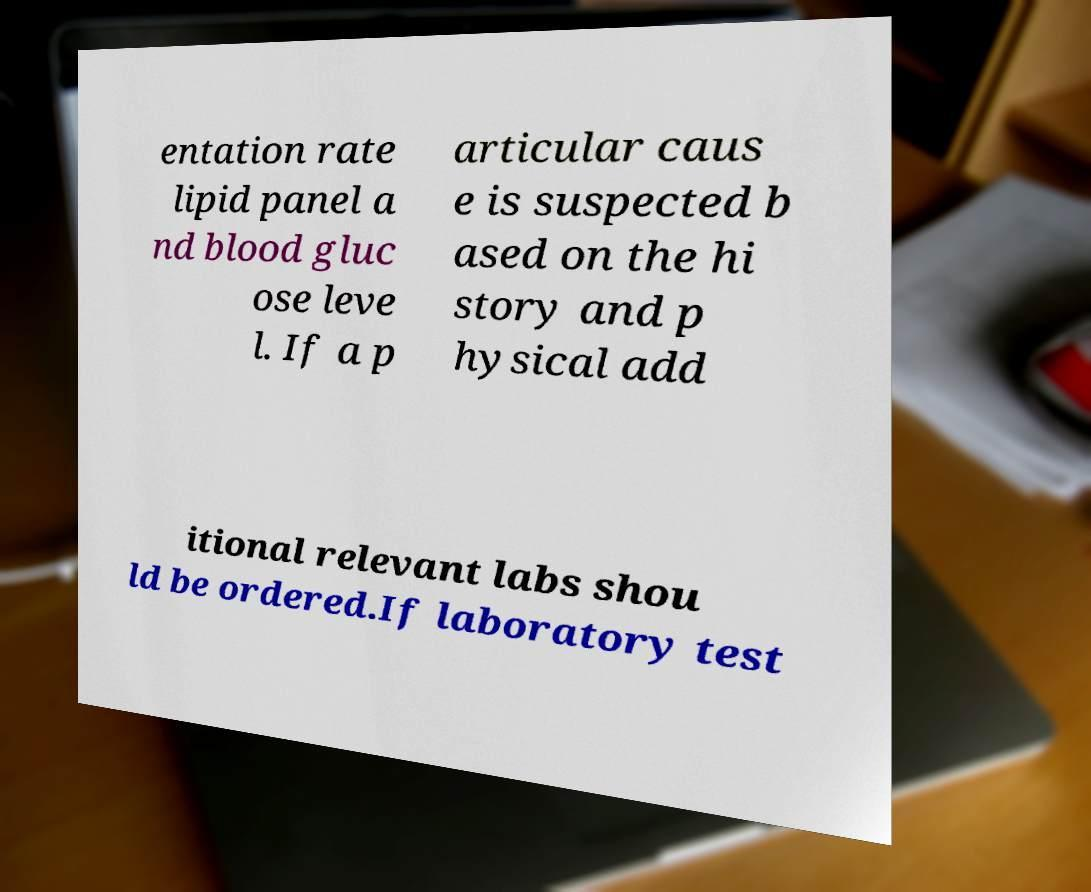For documentation purposes, I need the text within this image transcribed. Could you provide that? entation rate lipid panel a nd blood gluc ose leve l. If a p articular caus e is suspected b ased on the hi story and p hysical add itional relevant labs shou ld be ordered.If laboratory test 